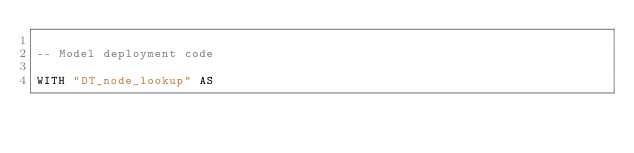<code> <loc_0><loc_0><loc_500><loc_500><_SQL_>
-- Model deployment code

WITH "DT_node_lookup" AS </code> 